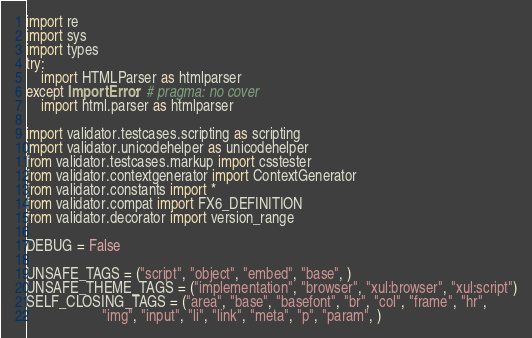<code> <loc_0><loc_0><loc_500><loc_500><_Python_>import re
import sys
import types
try:
    import HTMLParser as htmlparser
except ImportError:  # pragma: no cover
    import html.parser as htmlparser

import validator.testcases.scripting as scripting
import validator.unicodehelper as unicodehelper
from validator.testcases.markup import csstester
from validator.contextgenerator import ContextGenerator
from validator.constants import *
from validator.compat import FX6_DEFINITION
from validator.decorator import version_range

DEBUG = False

UNSAFE_TAGS = ("script", "object", "embed", "base", )
UNSAFE_THEME_TAGS = ("implementation", "browser", "xul:browser", "xul:script")
SELF_CLOSING_TAGS = ("area", "base", "basefont", "br", "col", "frame", "hr",
                     "img", "input", "li", "link", "meta", "p", "param", )</code> 